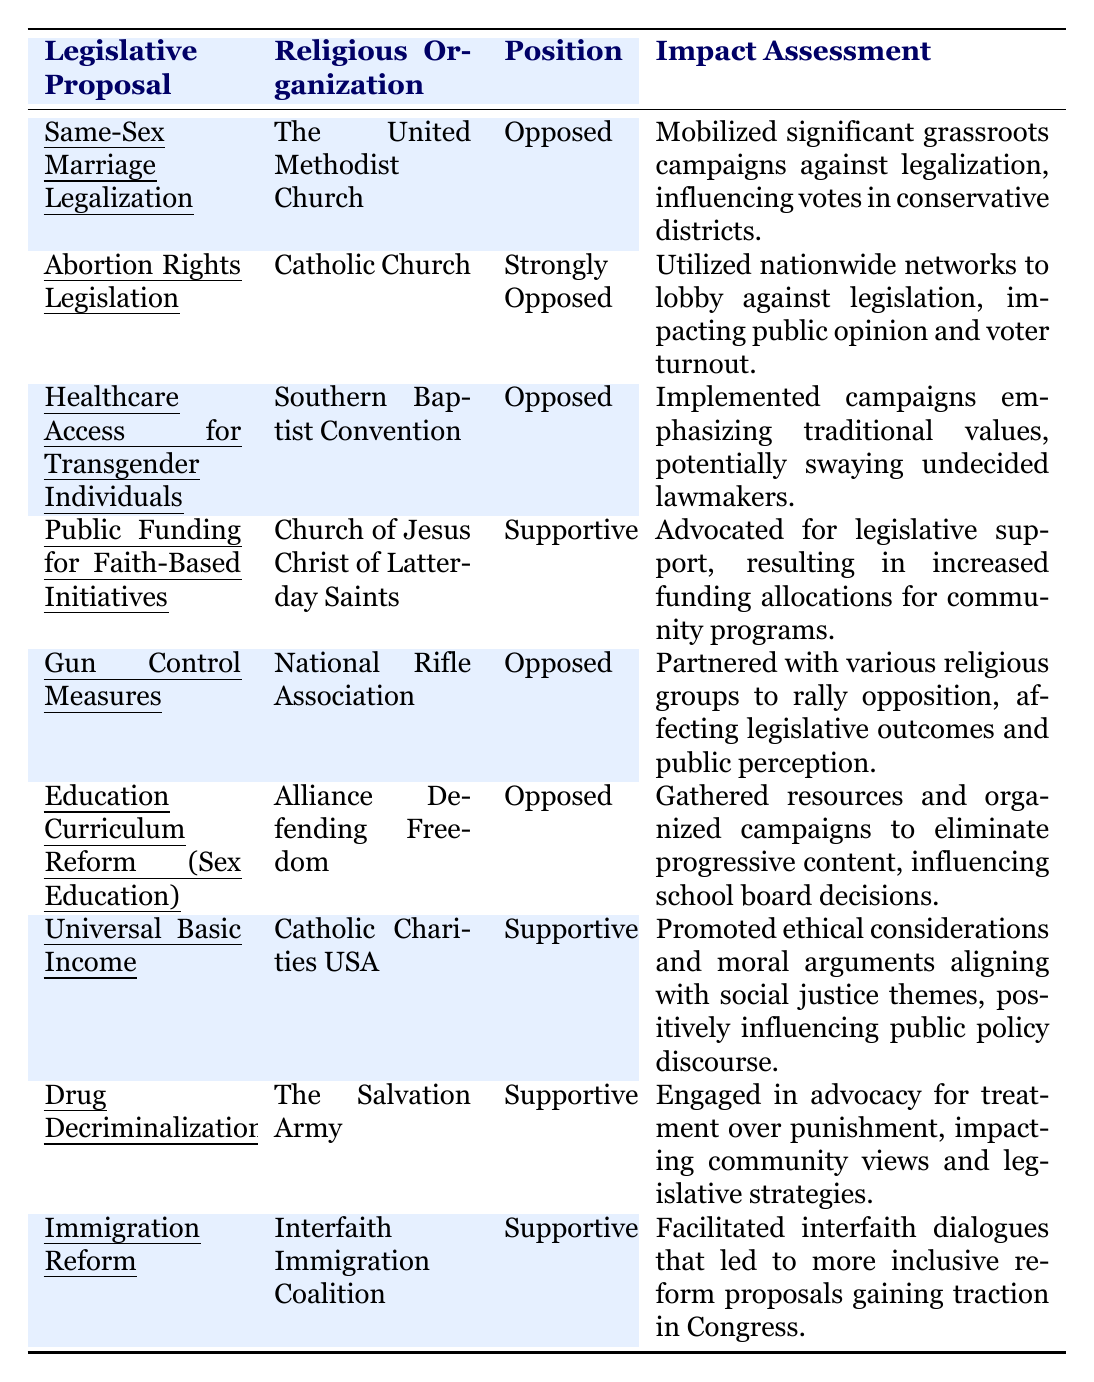What is the position of the Catholic Church on Abortion Rights Legislation? The table lists the Catholic Church's position on Abortion Rights Legislation as "Strongly Opposed."
Answer: Strongly Opposed How many legislative proposals are listed as supportive by religious organizations? The table shows three supportive positions: one by the Church of Jesus Christ of Latter-day Saints, one by Catholic Charities USA, and one by The Salvation Army, totaling three supportive proposals.
Answer: 3 Which religious organization opposed the legislative proposal for Gun Control Measures? The National Rifle Association is noted in the table as opposing Gun Control Measures.
Answer: National Rifle Association Did the Southern Baptist Convention support any legislative proposals according to the table? The table indicates that the Southern Baptist Convention opposed the legislative proposal for Healthcare Access for Transgender Individuals, meaning they did not support any proposal.
Answer: No What impact assessment was associated with the Interfaith Immigration Coalition regarding Immigration Reform? The Interfaith Immigration Coalition facilitated interfaith dialogues leading to more inclusive proposals, which reflects a positive impact on legislative proposals.
Answer: Facilitated interfaith dialogues leading to inclusive proposals Which organization had the most significant impact in terms of mobilizing grassroots campaigns according to the assessment? The United Methodist Church is recorded as mobilizing significant grassroots campaigns against Same-Sex Marriage Legalization, indicating a strong impact.
Answer: The United Methodist Church How many legislative proposals did religious organizations show opposition to according to the table? The table indicates that six proposals have an opposing position: Same-Sex Marriage Legalization, Abortion Rights Legislation, Healthcare Access for Transgender Individuals, Gun Control Measures, Education Curriculum Reform, and Immigration Reform, totaling six opposition proposals.
Answer: 6 Which legislative proposal saw support from both the Church of Jesus Christ of Latter-day Saints and Catholic Charities USA? The table lists the Church of Jesus Christ of Latter-day Saints supporting Public Funding for Faith-Based Initiatives and Catholic Charities USA supporting Universal Basic Income, which are different proposals, indicating no overlap in support.
Answer: No overlap in support What are the common themes in the impact assessments of the supportive religious organizations? The supportive organizations focused on ethical considerations, community programs, and advocacy for treatment over punishment, which are related to social justice and community welfare themes.
Answer: Ethical considerations and community welfare What legislative proposal had the most organized opposition concerning public opinion? The Catholic Church's lobbying against Abortion Rights Legislation utilized nationwide networks, showing that this proposal faced significant organized opposition in terms of public opinion.
Answer: Abortion Rights Legislation 